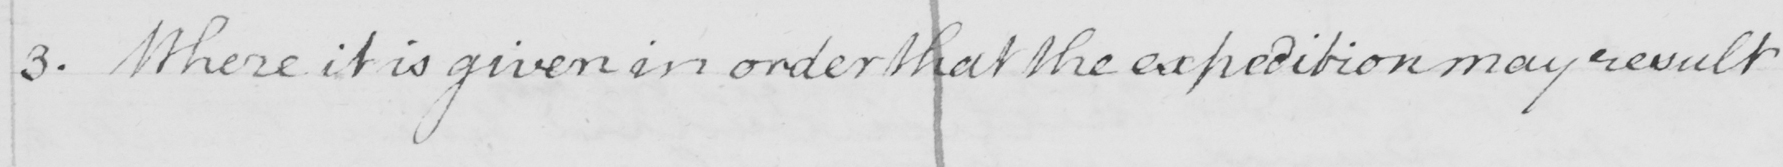What text is written in this handwritten line? 3 . Where it is given in order that the expedition may result 